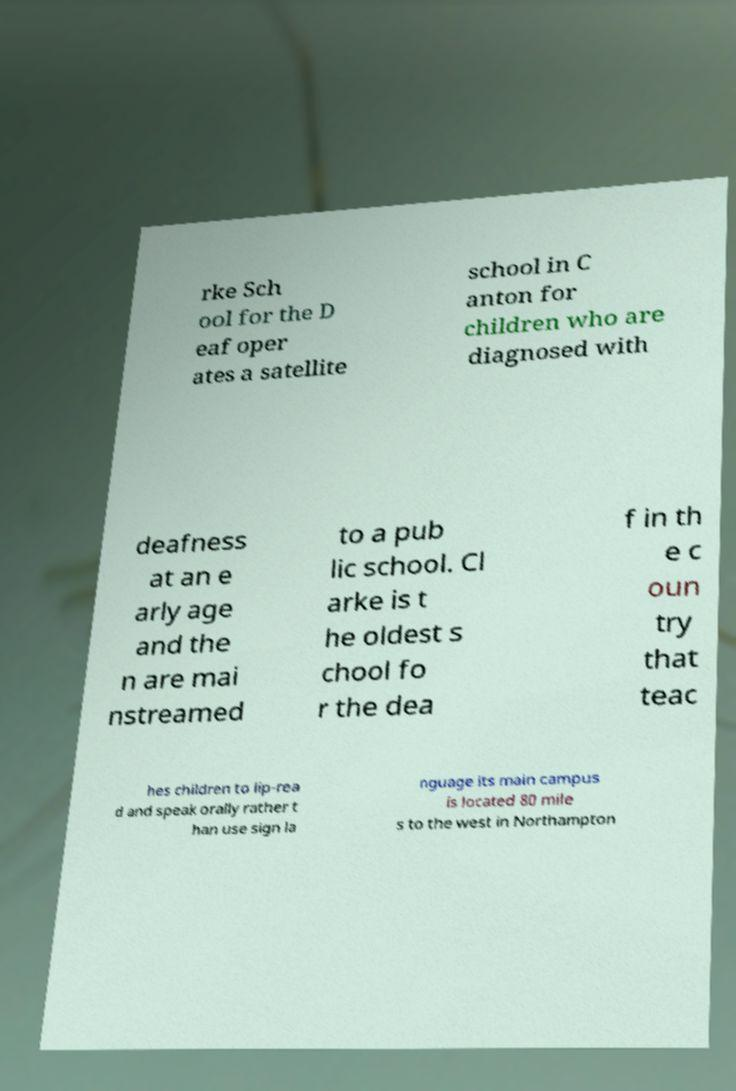Please read and relay the text visible in this image. What does it say? rke Sch ool for the D eaf oper ates a satellite school in C anton for children who are diagnosed with deafness at an e arly age and the n are mai nstreamed to a pub lic school. Cl arke is t he oldest s chool fo r the dea f in th e c oun try that teac hes children to lip-rea d and speak orally rather t han use sign la nguage its main campus is located 80 mile s to the west in Northampton 